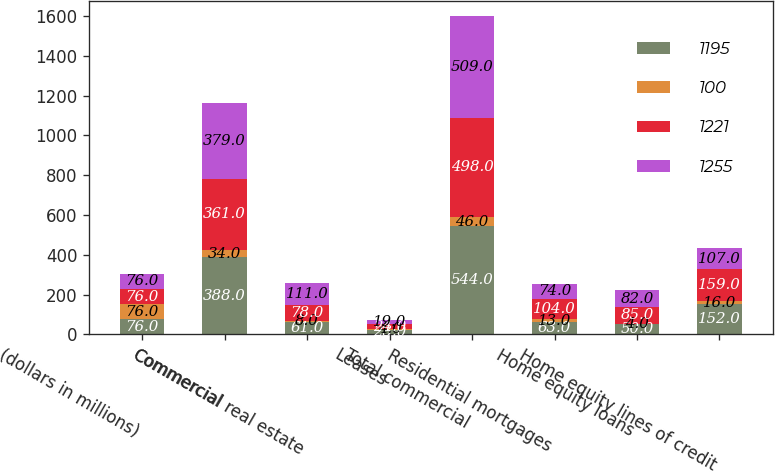Convert chart to OTSL. <chart><loc_0><loc_0><loc_500><loc_500><stacked_bar_chart><ecel><fcel>(dollars in millions)<fcel>Commercial<fcel>Commercial real estate<fcel>Leases<fcel>Total commercial<fcel>Residential mortgages<fcel>Home equity loans<fcel>Home equity lines of credit<nl><fcel>1195<fcel>76<fcel>388<fcel>61<fcel>23<fcel>544<fcel>63<fcel>50<fcel>152<nl><fcel>100<fcel>76<fcel>34<fcel>8<fcel>4<fcel>46<fcel>13<fcel>4<fcel>16<nl><fcel>1221<fcel>76<fcel>361<fcel>78<fcel>24<fcel>498<fcel>104<fcel>85<fcel>159<nl><fcel>1255<fcel>76<fcel>379<fcel>111<fcel>19<fcel>509<fcel>74<fcel>82<fcel>107<nl></chart> 